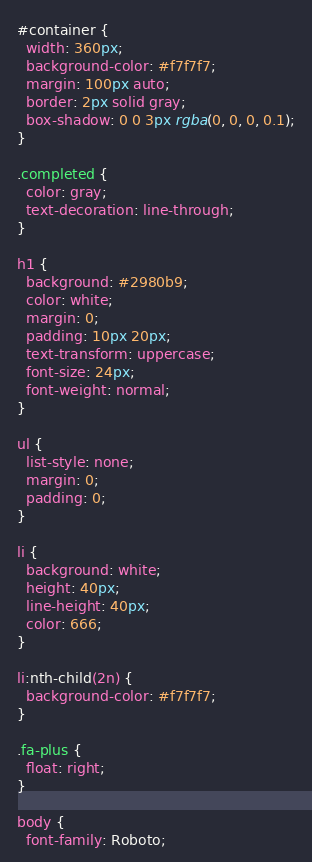Convert code to text. <code><loc_0><loc_0><loc_500><loc_500><_CSS_>#container {
  width: 360px;
  background-color: #f7f7f7;
  margin: 100px auto;
  border: 2px solid gray;
  box-shadow: 0 0 3px rgba(0, 0, 0, 0.1);
}

.completed {
  color: gray;
  text-decoration: line-through;
}

h1 {
  background: #2980b9;
  color: white;
  margin: 0;
  padding: 10px 20px;
  text-transform: uppercase;
  font-size: 24px;
  font-weight: normal;
}

ul {
  list-style: none;
  margin: 0;
  padding: 0;
}

li {
  background: white;
  height: 40px;
  line-height: 40px;
  color: 666;
}

li:nth-child(2n) {
  background-color: #f7f7f7;
}

.fa-plus {
  float: right;
}

body {
  font-family: Roboto;</code> 